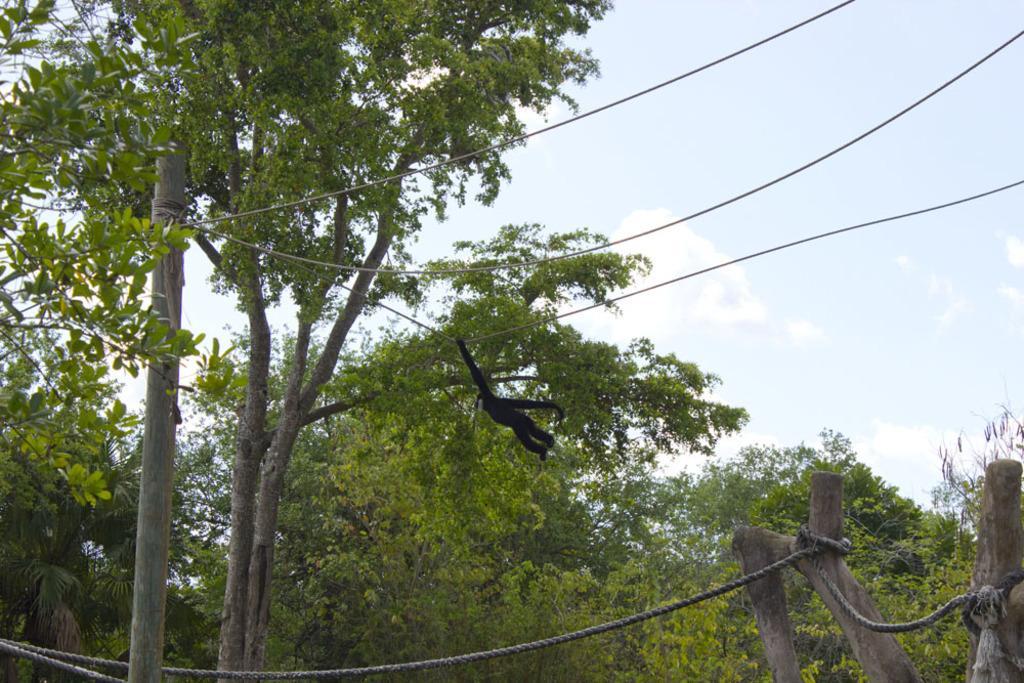Describe this image in one or two sentences. As we can see in the image there is a clear sky and this side there are lot of trees and the monkey is holding a rope and hanging on it and there is a rope tied to a tree log. 